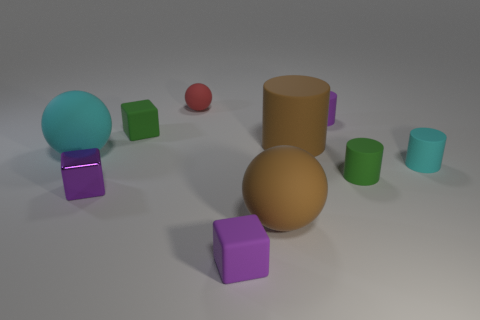Subtract 1 cylinders. How many cylinders are left? 3 Subtract all blocks. How many objects are left? 7 Add 1 gray cubes. How many gray cubes exist? 1 Subtract 0 blue spheres. How many objects are left? 10 Subtract all big cylinders. Subtract all metallic objects. How many objects are left? 8 Add 4 tiny purple matte cylinders. How many tiny purple matte cylinders are left? 5 